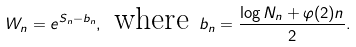<formula> <loc_0><loc_0><loc_500><loc_500>W _ { n } = e ^ { S _ { n } - b _ { n } } , \text { where } b _ { n } = \frac { \log N _ { n } + \varphi ( 2 ) n } { 2 } .</formula> 